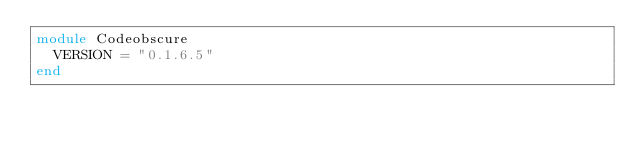Convert code to text. <code><loc_0><loc_0><loc_500><loc_500><_Ruby_>module Codeobscure
  VERSION = "0.1.6.5"
end
</code> 